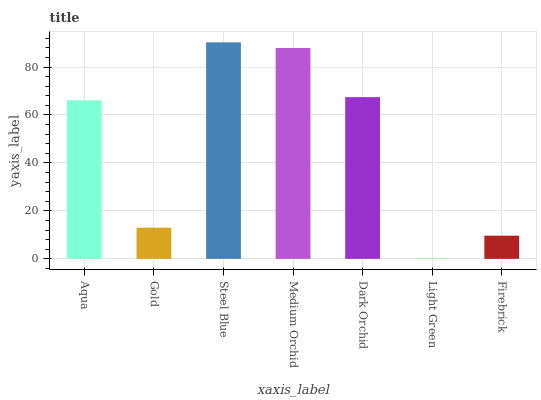Is Light Green the minimum?
Answer yes or no. Yes. Is Steel Blue the maximum?
Answer yes or no. Yes. Is Gold the minimum?
Answer yes or no. No. Is Gold the maximum?
Answer yes or no. No. Is Aqua greater than Gold?
Answer yes or no. Yes. Is Gold less than Aqua?
Answer yes or no. Yes. Is Gold greater than Aqua?
Answer yes or no. No. Is Aqua less than Gold?
Answer yes or no. No. Is Aqua the high median?
Answer yes or no. Yes. Is Aqua the low median?
Answer yes or no. Yes. Is Gold the high median?
Answer yes or no. No. Is Dark Orchid the low median?
Answer yes or no. No. 